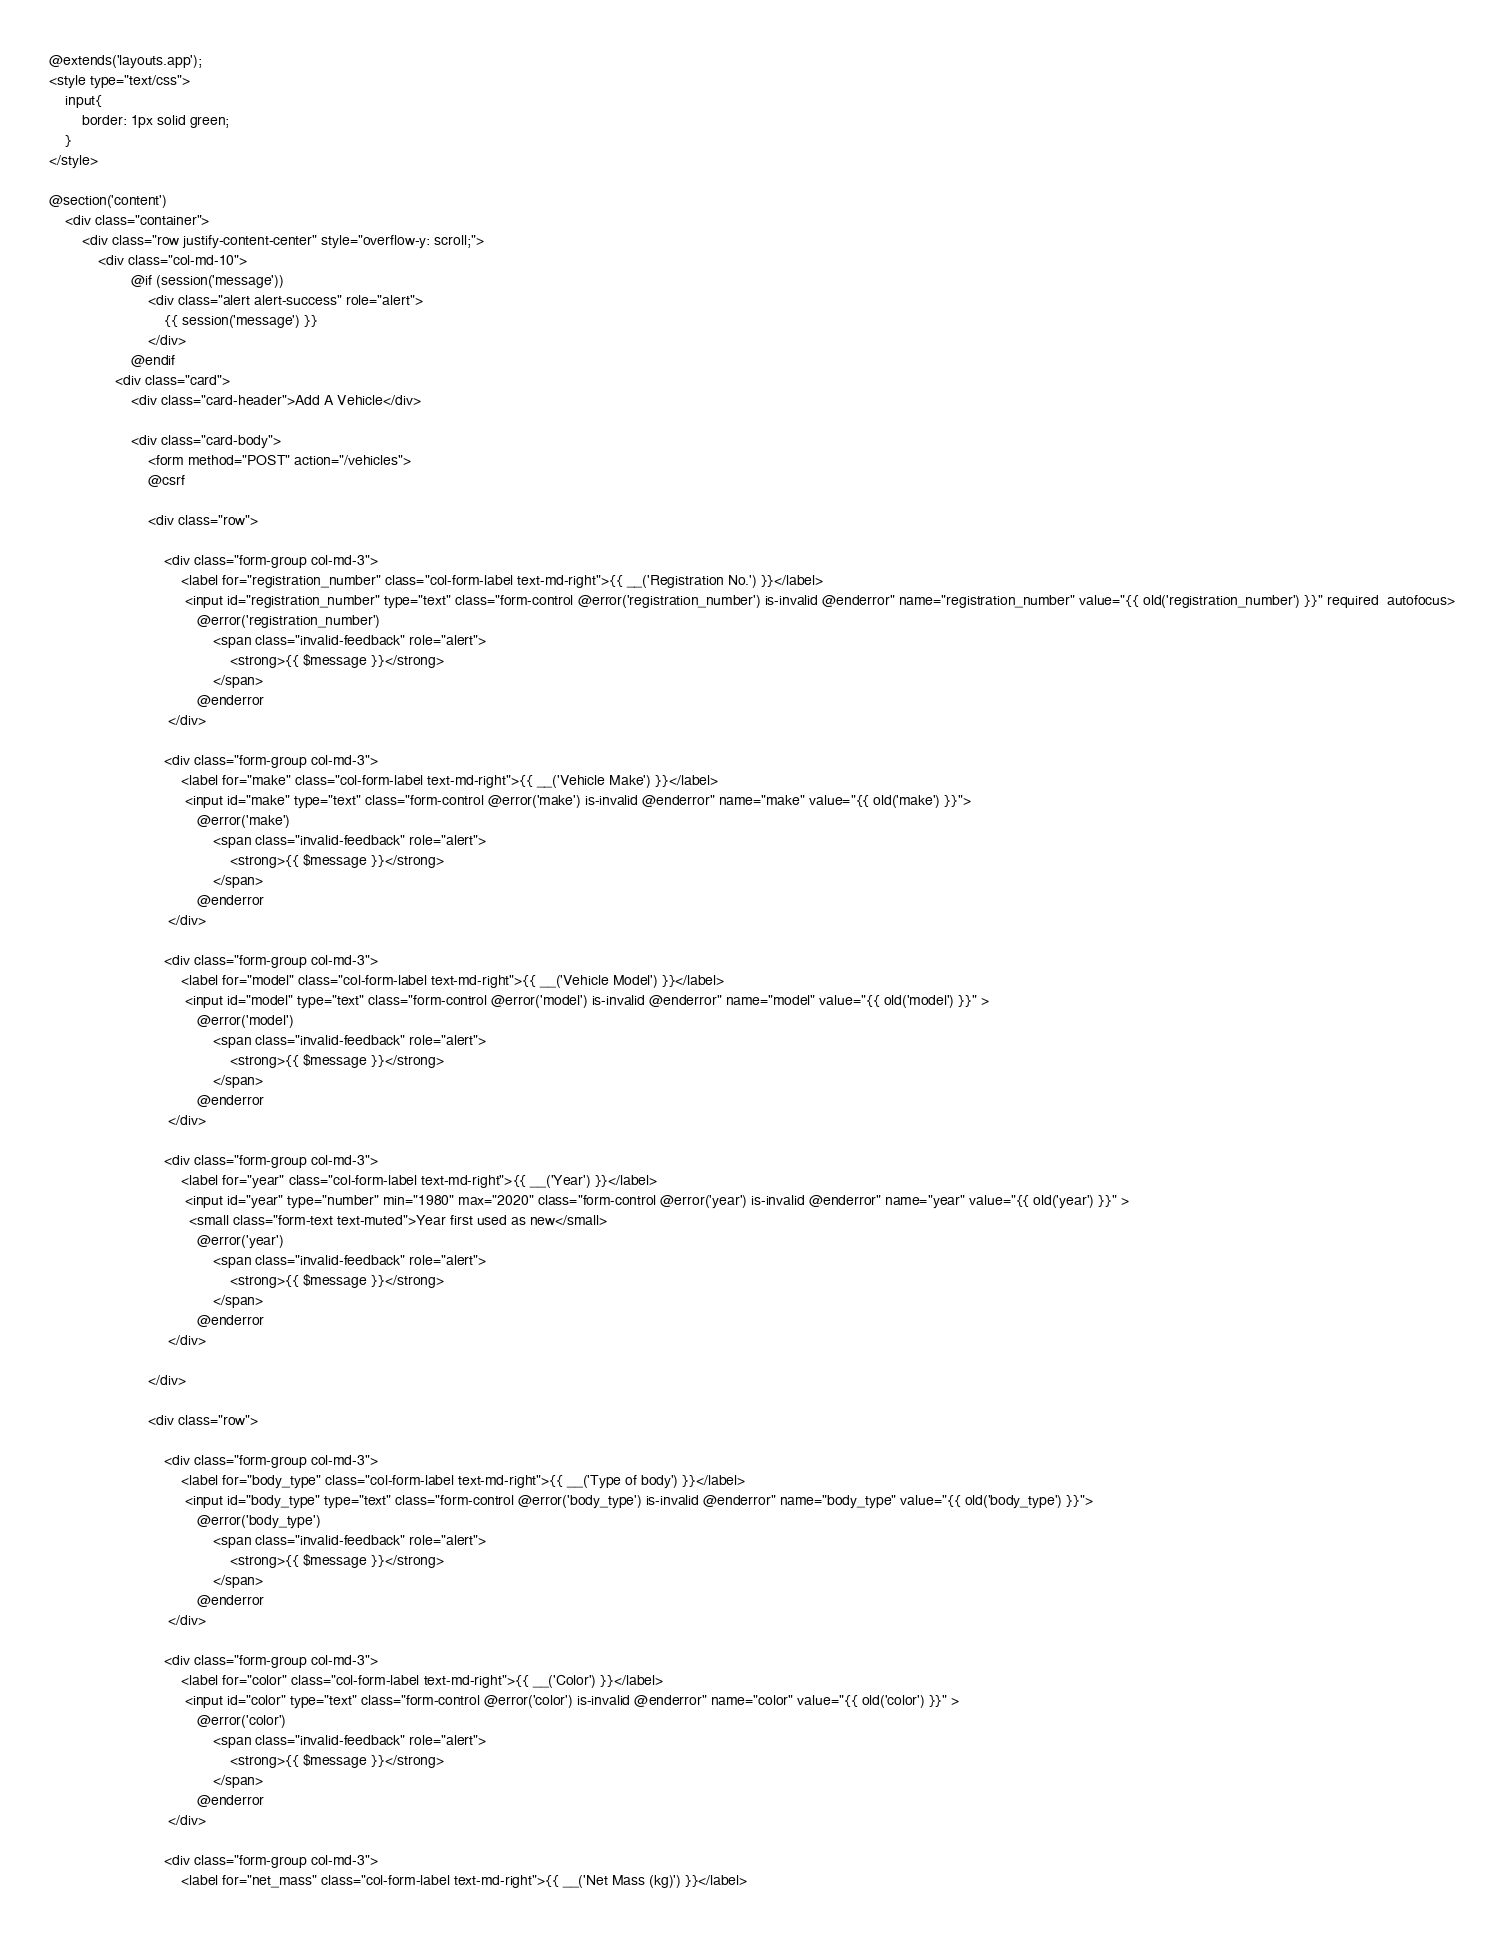Convert code to text. <code><loc_0><loc_0><loc_500><loc_500><_PHP_>@extends('layouts.app');
<style type="text/css">
	input{
		border: 1px solid green;
	}
</style>

@section('content')
	<div class="container">
	    <div class="row justify-content-center" style="overflow-y: scroll;">
	        <div class="col-md-10">
                    @if (session('message'))
                        <div class="alert alert-success" role="alert">
                            {{ session('message') }}
                        </div>
                    @endif	        	
	            <div class="card">
	                <div class="card-header">Add A Vehicle</div>

	                <div class="card-body">
						<form method="POST" action="/vehicles">
                        @csrf
						
						<div class="row">

	                        <div class="form-group col-md-3">                        	
	                            <label for="registration_number" class="col-form-label text-md-right">{{ __('Registration No.') }}</label>
	                             <input id="registration_number" type="text" class="form-control @error('registration_number') is-invalid @enderror" name="registration_number" value="{{ old('registration_number') }}" required  autofocus>
	                                @error('registration_number')
	                                    <span class="invalid-feedback" role="alert">
	                                        <strong>{{ $message }}</strong>
	                                    </span>
	                                @enderror
	                         </div>	

	                        <div class="form-group col-md-3">                        	
	                            <label for="make" class="col-form-label text-md-right">{{ __('Vehicle Make') }}</label>
	                             <input id="make" type="text" class="form-control @error('make') is-invalid @enderror" name="make" value="{{ old('make') }}">
	                                @error('make')
	                                    <span class="invalid-feedback" role="alert">
	                                        <strong>{{ $message }}</strong>
	                                    </span>
	                                @enderror
	                         </div>		                         

	                        <div class="form-group col-md-3">                        	
	                            <label for="model" class="col-form-label text-md-right">{{ __('Vehicle Model') }}</label>
	                             <input id="model" type="text" class="form-control @error('model') is-invalid @enderror" name="model" value="{{ old('model') }}" >
	                                @error('model')
	                                    <span class="invalid-feedback" role="alert">
	                                        <strong>{{ $message }}</strong>
	                                    </span>
	                                @enderror
	                         </div>	

	                        <div class="form-group col-md-3">                        	
	                            <label for="year" class="col-form-label text-md-right">{{ __('Year') }}</label>
	                             <input id="year" type="number" min="1980" max="2020" class="form-control @error('year') is-invalid @enderror" name="year" value="{{ old('year') }}" >
	                              <small class="form-text text-muted">Year first used as new</small>
	                                @error('year')
	                                    <span class="invalid-feedback" role="alert">
	                                        <strong>{{ $message }}</strong>
	                                    </span>
	                                @enderror
	                         </div>	                                                 						

						</div>

						<div class="row">

	                        <div class="form-group col-md-3">                        	
	                            <label for="body_type" class="col-form-label text-md-right">{{ __('Type of body') }}</label>
	                             <input id="body_type" type="text" class="form-control @error('body_type') is-invalid @enderror" name="body_type" value="{{ old('body_type') }}">
	                                @error('body_type')
	                                    <span class="invalid-feedback" role="alert">
	                                        <strong>{{ $message }}</strong>
	                                    </span>
	                                @enderror
	                         </div>	

	                        <div class="form-group col-md-3">                        	
	                            <label for="color" class="col-form-label text-md-right">{{ __('Color') }}</label>
	                             <input id="color" type="text" class="form-control @error('color') is-invalid @enderror" name="color" value="{{ old('color') }}" >
	                                @error('color')
	                                    <span class="invalid-feedback" role="alert">
	                                        <strong>{{ $message }}</strong>
	                                    </span>
	                                @enderror
	                         </div>	

	                        <div class="form-group col-md-3">                        	
	                            <label for="net_mass" class="col-form-label text-md-right">{{ __('Net Mass (kg)') }}</label></code> 